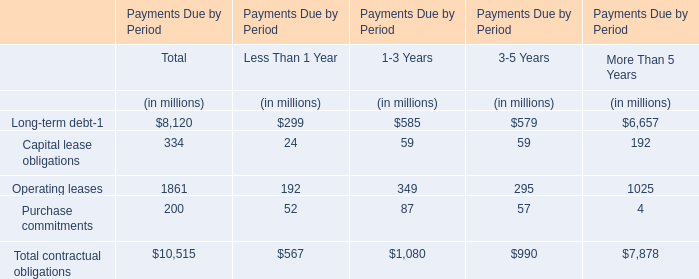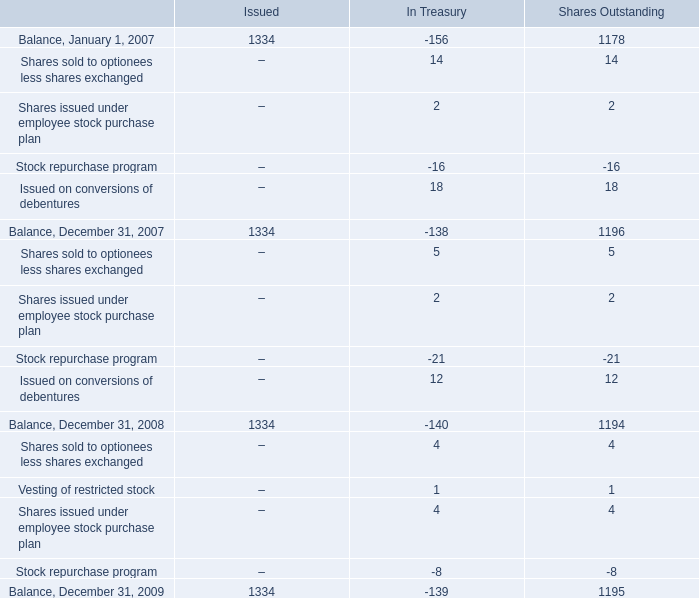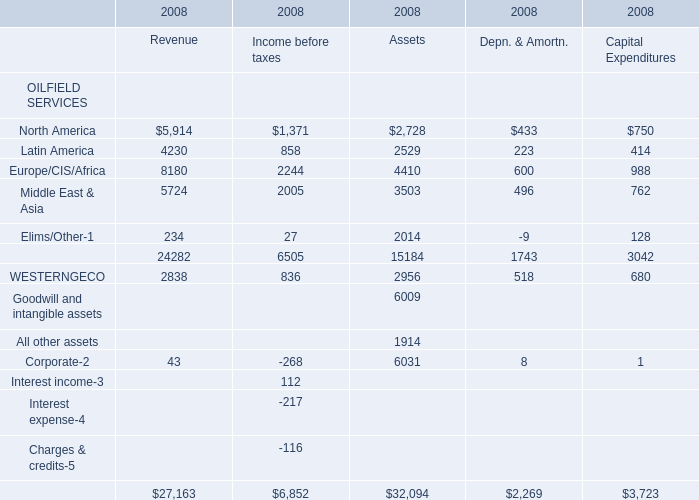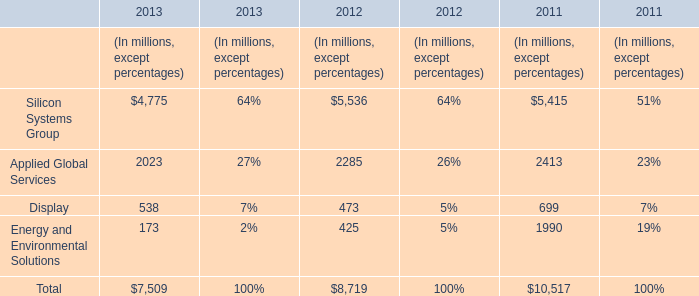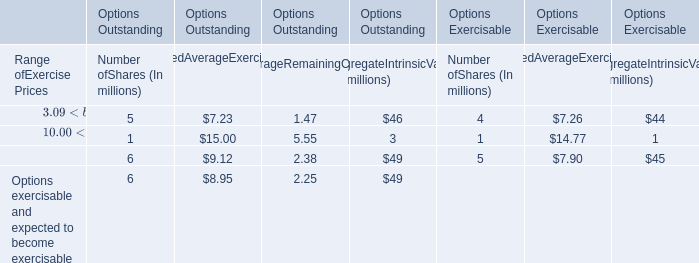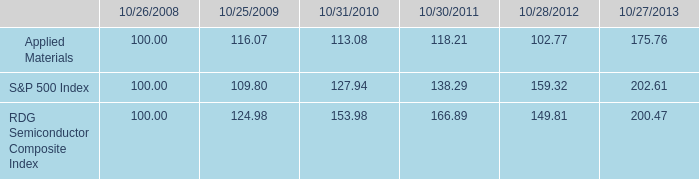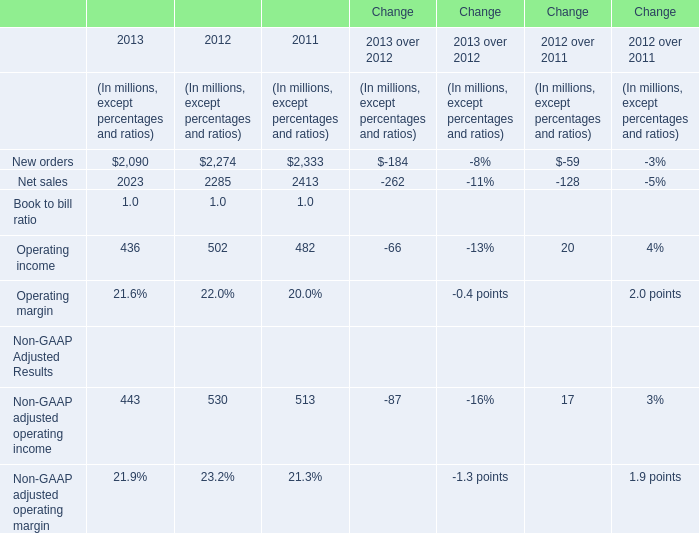What's the average of the Silicon Systems Group in the years where Net sales is positive? (in million) 
Computations: (((4775 + 5536) + 5415) / 3)
Answer: 5242.0. 